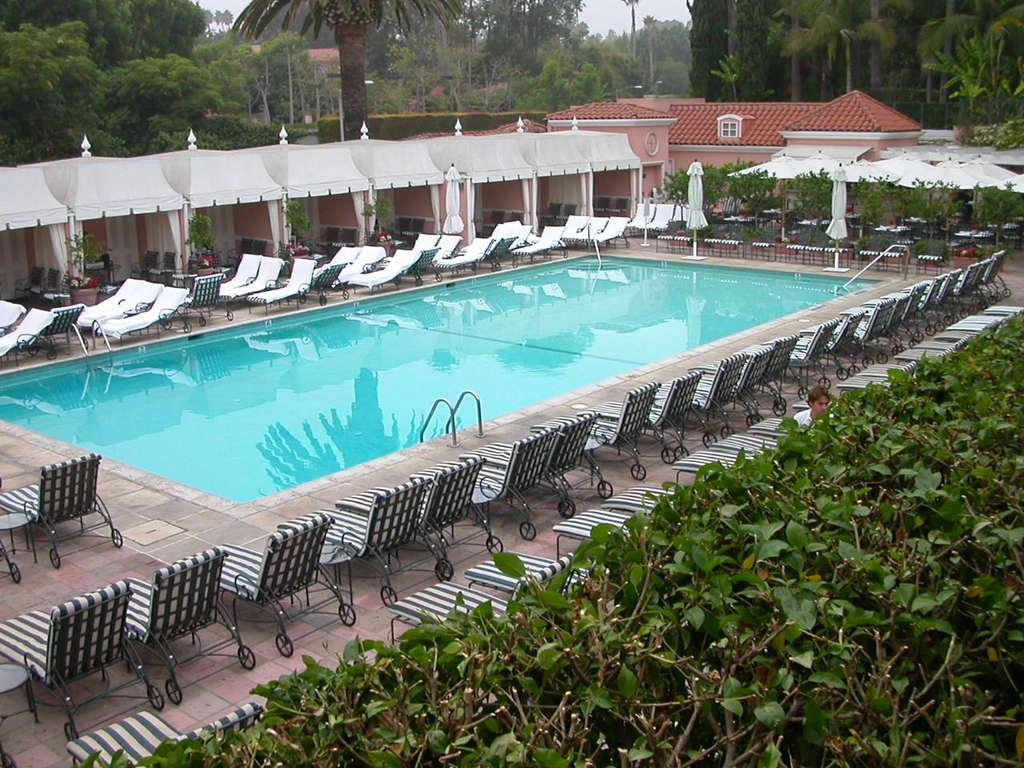What type of water feature is in the image? There is a swimming pool in the image. What can be found around the pool? Chairs are present around the pool, and bushes are visible around the pool. What type of structure is in the image? There is a house in the image. What is visible at the top of the image? The sky is visible at the top of the image. What game is being played on the water in the image? There is no game being played on the water in the image; it is a swimming pool. Can you see anyone running around the pool in the image? There is no one running around the pool in the image. 